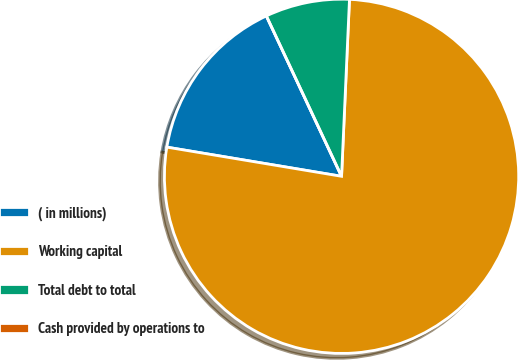Convert chart. <chart><loc_0><loc_0><loc_500><loc_500><pie_chart><fcel>( in millions)<fcel>Working capital<fcel>Total debt to total<fcel>Cash provided by operations to<nl><fcel>15.39%<fcel>76.92%<fcel>7.69%<fcel>0.0%<nl></chart> 